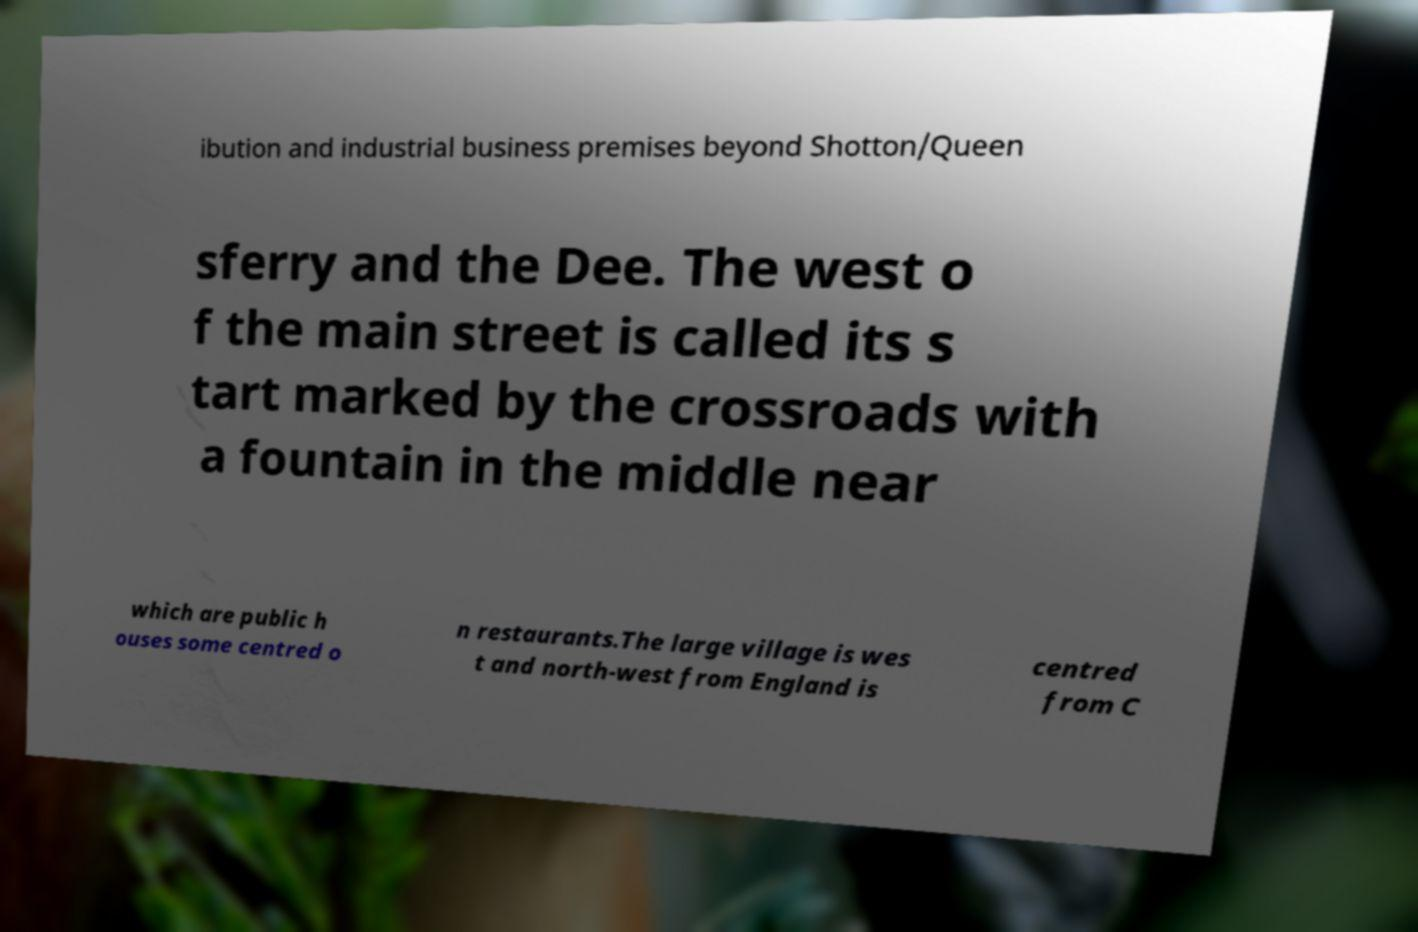Can you read and provide the text displayed in the image?This photo seems to have some interesting text. Can you extract and type it out for me? ibution and industrial business premises beyond Shotton/Queen sferry and the Dee. The west o f the main street is called its s tart marked by the crossroads with a fountain in the middle near which are public h ouses some centred o n restaurants.The large village is wes t and north-west from England is centred from C 